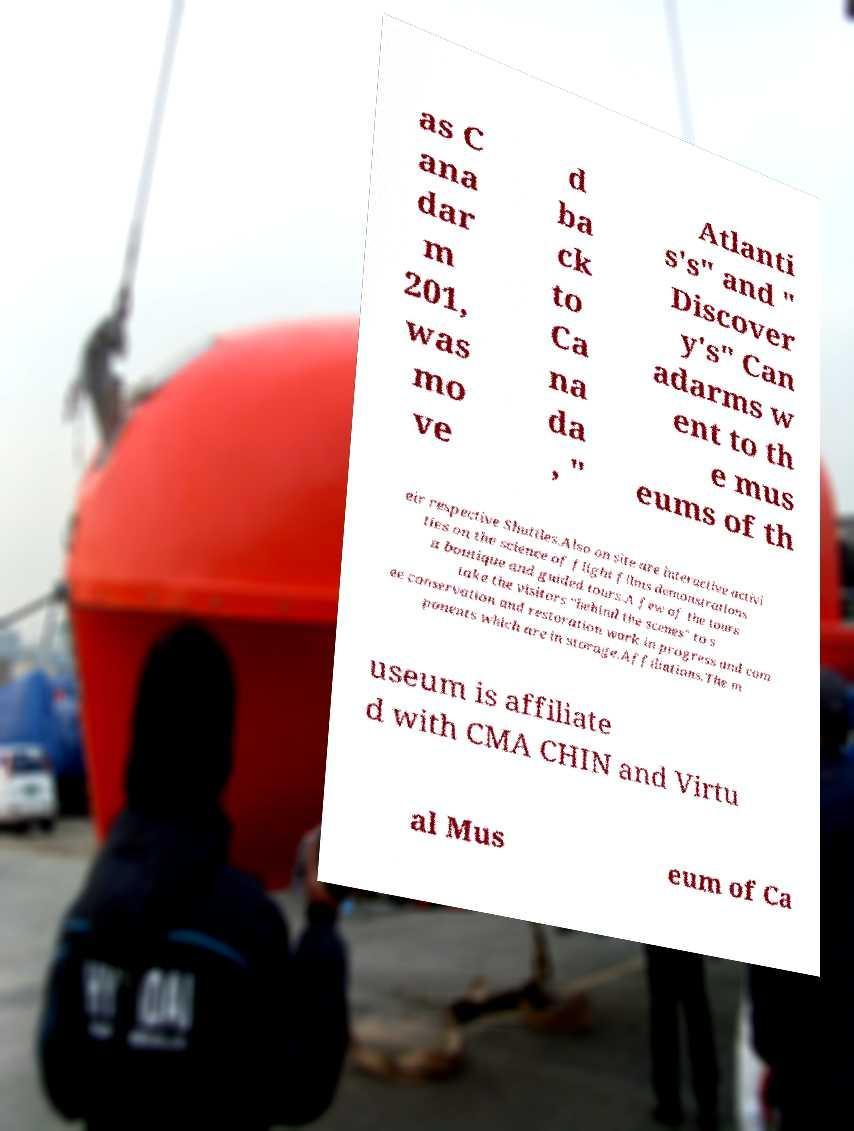Please identify and transcribe the text found in this image. as C ana dar m 201, was mo ve d ba ck to Ca na da , " Atlanti s's" and " Discover y's" Can adarms w ent to th e mus eums of th eir respective Shuttles.Also on site are interactive activi ties on the science of flight films demonstrations a boutique and guided tours.A few of the tours take the visitors "behind the scenes" to s ee conservation and restoration work in progress and com ponents which are in storage.Affiliations.The m useum is affiliate d with CMA CHIN and Virtu al Mus eum of Ca 